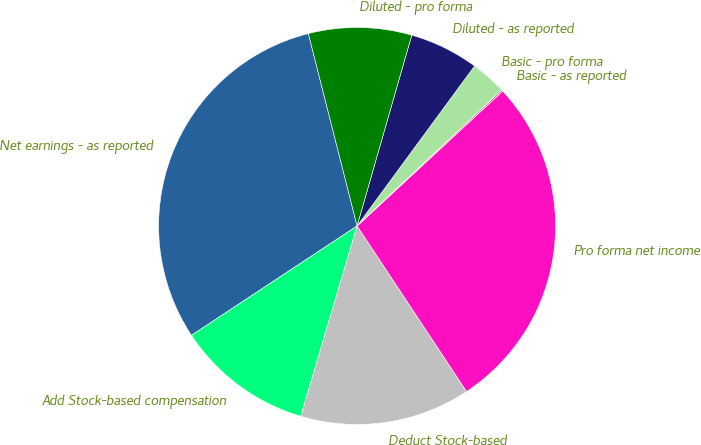Convert chart to OTSL. <chart><loc_0><loc_0><loc_500><loc_500><pie_chart><fcel>Net earnings - as reported<fcel>Add Stock-based compensation<fcel>Deduct Stock-based<fcel>Pro forma net income<fcel>Basic - as reported<fcel>Basic - pro forma<fcel>Diluted - as reported<fcel>Diluted - pro forma<nl><fcel>30.34%<fcel>11.13%<fcel>13.88%<fcel>27.59%<fcel>0.14%<fcel>2.89%<fcel>5.64%<fcel>8.39%<nl></chart> 